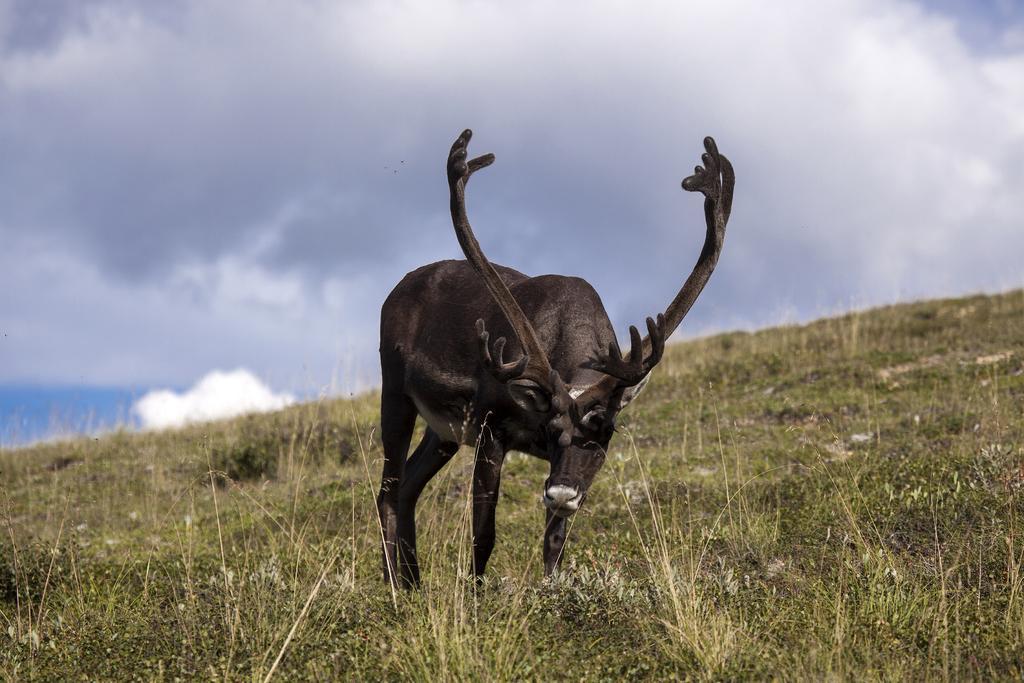Can you describe this image briefly? In this picture I can see there is a reindeer standing on a mountain cliff and on the floor I can see there is grass and the sky is clear. 